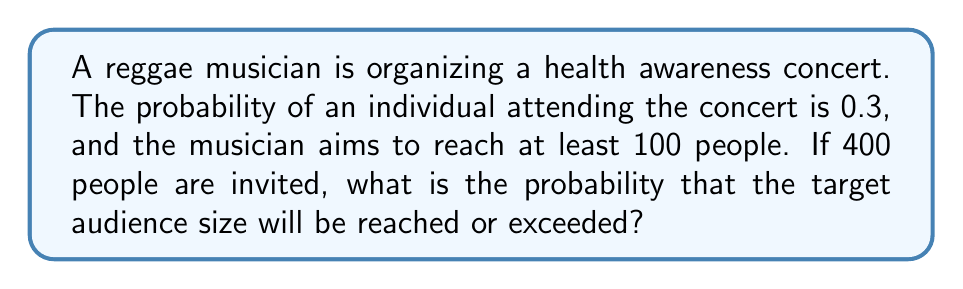Solve this math problem. Let's approach this step-by-step using the binomial distribution:

1) Let X be the number of people who attend the concert.

2) We have:
   n = 400 (number of invited people)
   p = 0.3 (probability of an individual attending)
   x ≥ 100 (we want at least 100 people to attend)

3) X follows a binomial distribution: X ~ B(400, 0.3)

4) We need to calculate P(X ≥ 100)

5) This is equivalent to 1 - P(X < 100) = 1 - P(X ≤ 99)

6) For large n and np > 5, we can approximate the binomial distribution with a normal distribution:

   μ = np = 400 * 0.3 = 120
   σ² = np(1-p) = 400 * 0.3 * 0.7 = 84
   σ = √84 ≈ 9.17

7) Using the normal approximation:

   P(X ≤ 99) ≈ P(Z ≤ (99.5 - 120) / 9.17) = P(Z ≤ -2.24)

   Note: We use 99.5 instead of 99 for continuity correction.

8) Using a standard normal table or calculator:

   P(Z ≤ -2.24) ≈ 0.0125

9) Therefore, P(X ≥ 100) = 1 - P(X ≤ 99) ≈ 1 - 0.0125 = 0.9875
Answer: 0.9875 